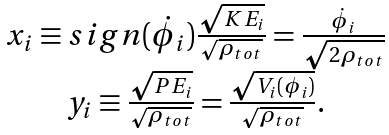Convert formula to latex. <formula><loc_0><loc_0><loc_500><loc_500>\begin{array} { c } x _ { i } \equiv s i g n ( \dot { \phi } _ { i } ) \frac { \sqrt { K E _ { i } } } { \sqrt { \rho _ { t o t } } } = \frac { \dot { \phi } _ { i } } { \sqrt { 2 \rho _ { t o t } } } \\ y _ { i } \equiv \frac { \sqrt { P E _ { i } } } { \sqrt { \rho _ { t o t } } } = \frac { \sqrt { V _ { i } ( \phi _ { i } ) } } { \sqrt { \rho _ { t o t } } } . \end{array}</formula> 